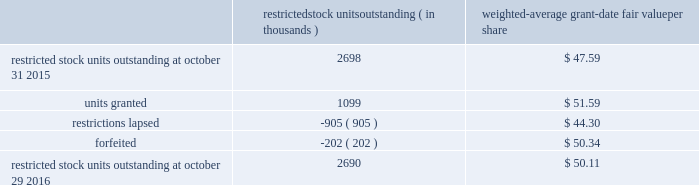Analog devices , inc .
Notes to consolidated financial statements 2014 ( continued ) the total intrinsic value of options exercised ( i.e .
The difference between the market price at exercise and the price paid by the employee to exercise the options ) during fiscal 2016 , 2015 and 2014 was $ 46.6 million , $ 99.2 million and $ 130.6 million , respectively , and the total amount of proceeds received by the company from exercise of these options during fiscal 2016 , 2015 and 2014 was $ 61.5 million , $ 122.6 million and $ 200.1 million , respectively .
A summary of the company 2019s restricted stock unit award activity as of october 29 , 2016 and changes during the fiscal year then ended is presented below : restricted stock units outstanding ( in thousands ) weighted- average grant- date fair value per share .
As of october 29 , 2016 , there was $ 112.3 million of total unrecognized compensation cost related to unvested share- based awards comprised of stock options and restricted stock units .
That cost is expected to be recognized over a weighted- average period of 1.4 years .
The total grant-date fair value of shares that vested during fiscal 2016 , 2015 and 2014 was approximately $ 62.8 million , $ 65.6 million and $ 57.4 million , respectively .
Common stock repurchases the company 2019s common stock repurchase program has been in place since august 2004 .
In the aggregate , the board of directors has authorized the company to repurchase $ 6.2 billion of the company 2019s common stock under the program .
The company may repurchase outstanding shares of its common stock from time to time in the open market and through privately negotiated transactions .
Unless terminated earlier by resolution of the company 2019s board of directors , the repurchase program will expire when the company has repurchased all shares authorized under the program .
As of october 29 , 2016 , the company had repurchased a total of approximately 147.0 million shares of its common stock for approximately $ 5.4 billion under this program .
An additional $ 792.5 million remains available for repurchase of shares under the current authorized program .
The repurchased shares are held as authorized but unissued shares of common stock .
As a result of the company's planned acquisition of linear technology corporation , see note 6 , acquisitions , of these notes to consolidated financial statements , the company temporarily suspended the common stock repurchase plan in the third quarter of 2016 .
The company also , from time to time , repurchases shares in settlement of employee minimum tax withholding obligations due upon the vesting of restricted stock units or the exercise of stock options .
The withholding amount is based on the employees minimum statutory withholding requirement .
Any future common stock repurchases will be dependent upon several factors , including the company's financial performance , outlook , liquidity and the amount of cash the company has available in the united states .
Preferred stock the company has 471934 authorized shares of $ 1.00 par value preferred stock , none of which is issued or outstanding .
The board of directors is authorized to fix designations , relative rights , preferences and limitations on the preferred stock at the time of issuance. .
What is the total value of the forfeited shares? 
Computations: (202 * 50.34)
Answer: 10168.68. Analog devices , inc .
Notes to consolidated financial statements 2014 ( continued ) the total intrinsic value of options exercised ( i.e .
The difference between the market price at exercise and the price paid by the employee to exercise the options ) during fiscal 2016 , 2015 and 2014 was $ 46.6 million , $ 99.2 million and $ 130.6 million , respectively , and the total amount of proceeds received by the company from exercise of these options during fiscal 2016 , 2015 and 2014 was $ 61.5 million , $ 122.6 million and $ 200.1 million , respectively .
A summary of the company 2019s restricted stock unit award activity as of october 29 , 2016 and changes during the fiscal year then ended is presented below : restricted stock units outstanding ( in thousands ) weighted- average grant- date fair value per share .
As of october 29 , 2016 , there was $ 112.3 million of total unrecognized compensation cost related to unvested share- based awards comprised of stock options and restricted stock units .
That cost is expected to be recognized over a weighted- average period of 1.4 years .
The total grant-date fair value of shares that vested during fiscal 2016 , 2015 and 2014 was approximately $ 62.8 million , $ 65.6 million and $ 57.4 million , respectively .
Common stock repurchases the company 2019s common stock repurchase program has been in place since august 2004 .
In the aggregate , the board of directors has authorized the company to repurchase $ 6.2 billion of the company 2019s common stock under the program .
The company may repurchase outstanding shares of its common stock from time to time in the open market and through privately negotiated transactions .
Unless terminated earlier by resolution of the company 2019s board of directors , the repurchase program will expire when the company has repurchased all shares authorized under the program .
As of october 29 , 2016 , the company had repurchased a total of approximately 147.0 million shares of its common stock for approximately $ 5.4 billion under this program .
An additional $ 792.5 million remains available for repurchase of shares under the current authorized program .
The repurchased shares are held as authorized but unissued shares of common stock .
As a result of the company's planned acquisition of linear technology corporation , see note 6 , acquisitions , of these notes to consolidated financial statements , the company temporarily suspended the common stock repurchase plan in the third quarter of 2016 .
The company also , from time to time , repurchases shares in settlement of employee minimum tax withholding obligations due upon the vesting of restricted stock units or the exercise of stock options .
The withholding amount is based on the employees minimum statutory withholding requirement .
Any future common stock repurchases will be dependent upon several factors , including the company's financial performance , outlook , liquidity and the amount of cash the company has available in the united states .
Preferred stock the company has 471934 authorized shares of $ 1.00 par value preferred stock , none of which is issued or outstanding .
The board of directors is authorized to fix designations , relative rights , preferences and limitations on the preferred stock at the time of issuance. .
What is the percentage change in the total grant-date fair value of shares vested in 2016 compare to 2015? 
Computations: ((62.8 - 65.6) / 65.6)
Answer: -0.04268. 